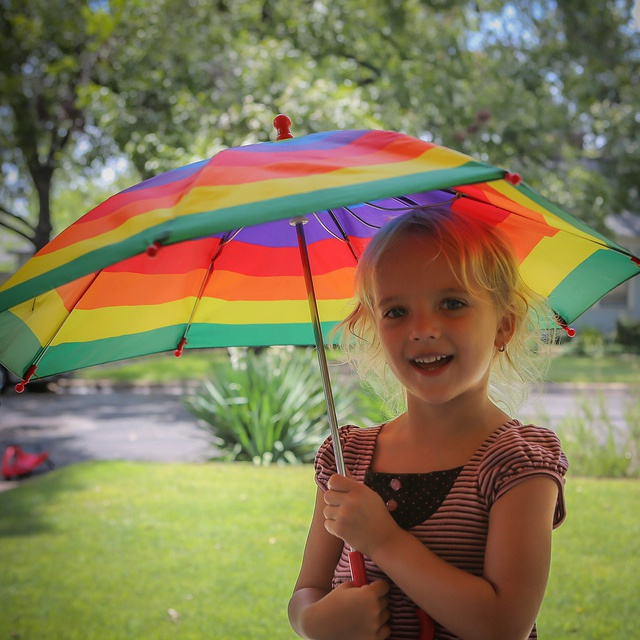Describe the objects in this image and their specific colors. I can see umbrella in black, red, and teal tones and people in black, maroon, and brown tones in this image. 